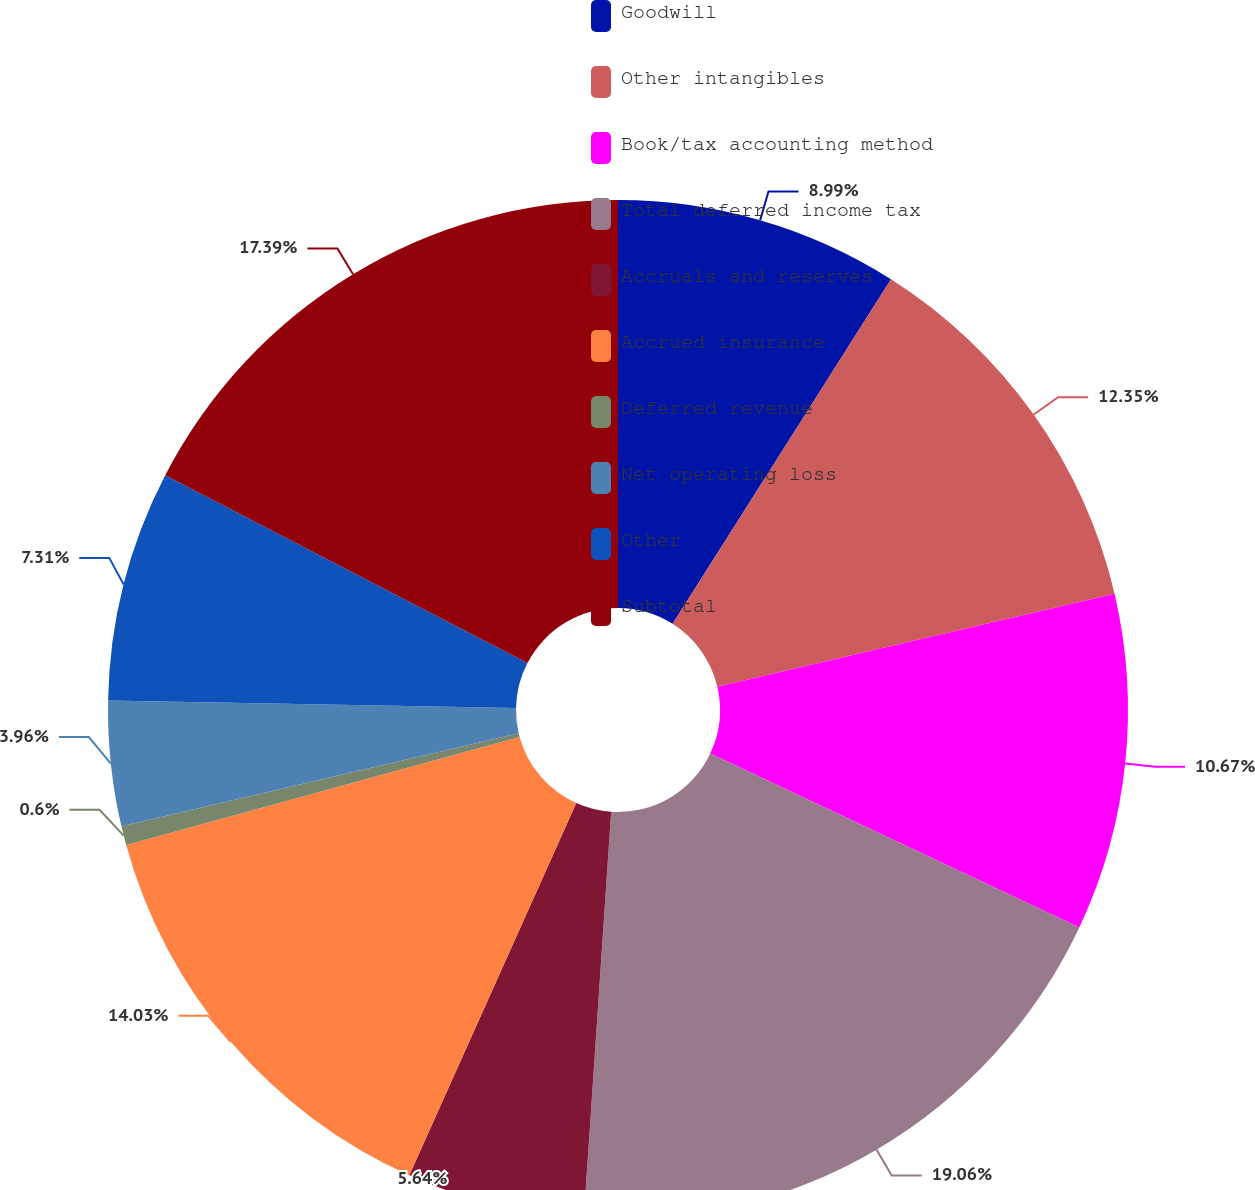Convert chart to OTSL. <chart><loc_0><loc_0><loc_500><loc_500><pie_chart><fcel>Goodwill<fcel>Other intangibles<fcel>Book/tax accounting method<fcel>Total deferred income tax<fcel>Accruals and reserves<fcel>Accrued insurance<fcel>Deferred revenue<fcel>Net operating loss<fcel>Other<fcel>Subtotal<nl><fcel>8.99%<fcel>12.35%<fcel>10.67%<fcel>19.06%<fcel>5.64%<fcel>14.03%<fcel>0.6%<fcel>3.96%<fcel>7.31%<fcel>17.39%<nl></chart> 